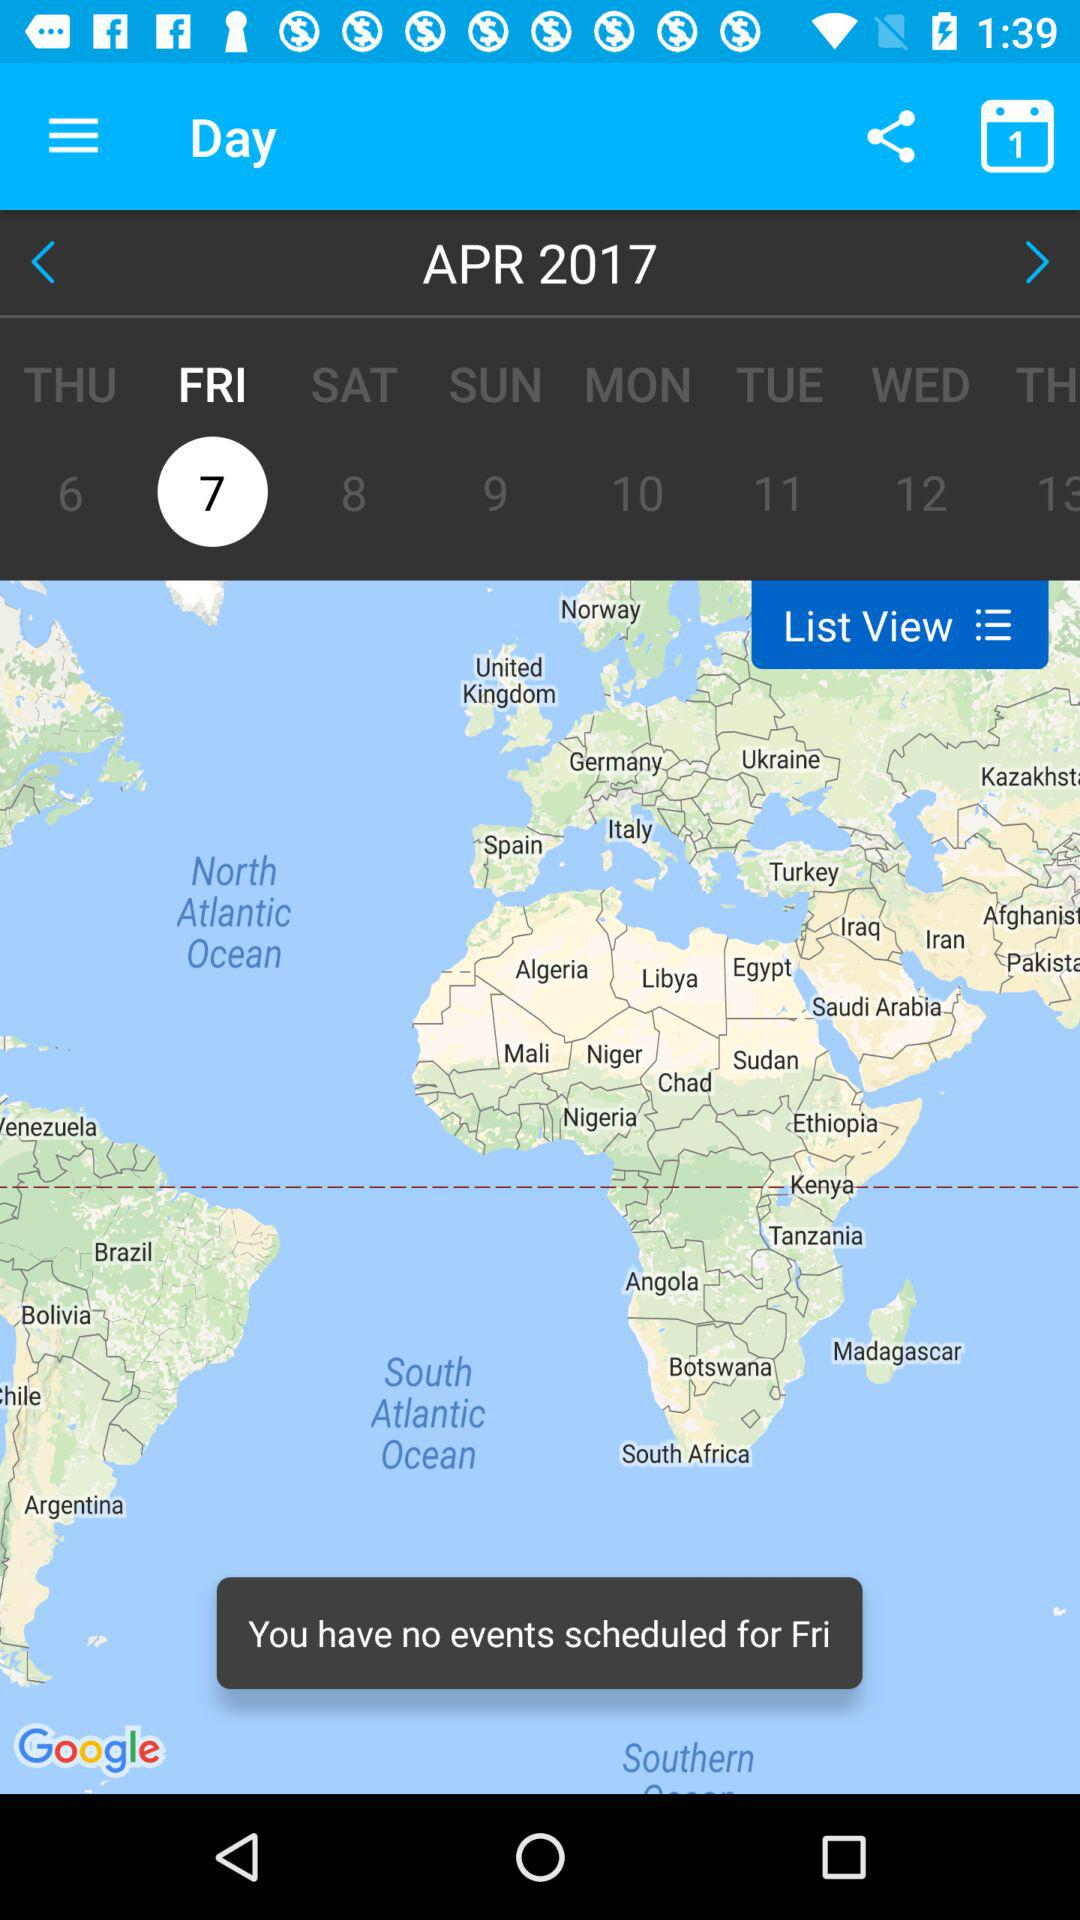What is the month? The month is April. 